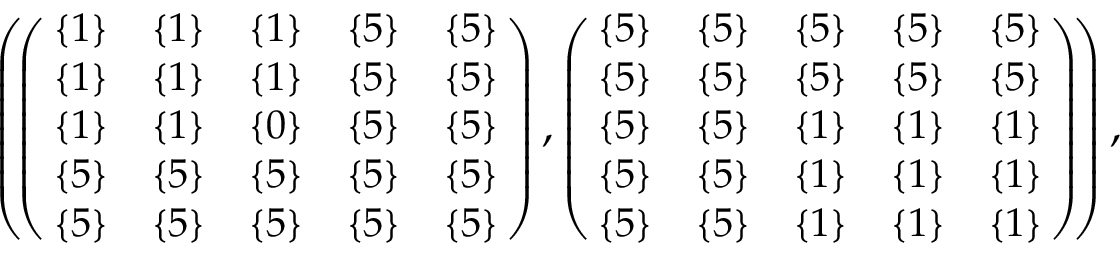<formula> <loc_0><loc_0><loc_500><loc_500>\begin{array} { r } { \left ( \, \left ( \, \begin{array} { c c c c c } { \{ 1 \} } & { \{ 1 \} } & { \{ 1 \} } & { \{ 5 \} } & { \{ 5 \} } \\ { \{ 1 \} } & { \{ 1 \} } & { \{ 1 \} } & { \{ 5 \} } & { \{ 5 \} } \\ { \{ 1 \} } & { \{ 1 \} } & { \{ 0 \} } & { \{ 5 \} } & { \{ 5 \} } \\ { \{ 5 \} } & { \{ 5 \} } & { \{ 5 \} } & { \{ 5 \} } & { \{ 5 \} } \\ { \{ 5 \} } & { \{ 5 \} } & { \{ 5 \} } & { \{ 5 \} } & { \{ 5 \} } \end{array} \, \right ) , \left ( \, \begin{array} { c c c c c } { \{ 5 \} } & { \{ 5 \} } & { \{ 5 \} } & { \{ 5 \} } & { \{ 5 \} } \\ { \{ 5 \} } & { \{ 5 \} } & { \{ 5 \} } & { \{ 5 \} } & { \{ 5 \} } \\ { \{ 5 \} } & { \{ 5 \} } & { \{ 1 \} } & { \{ 1 \} } & { \{ 1 \} } \\ { \{ 5 \} } & { \{ 5 \} } & { \{ 1 \} } & { \{ 1 \} } & { \{ 1 \} } \\ { \{ 5 \} } & { \{ 5 \} } & { \{ 1 \} } & { \{ 1 \} } & { \{ 1 \} } \end{array} \, \right ) \, \right ) , } \end{array}</formula> 